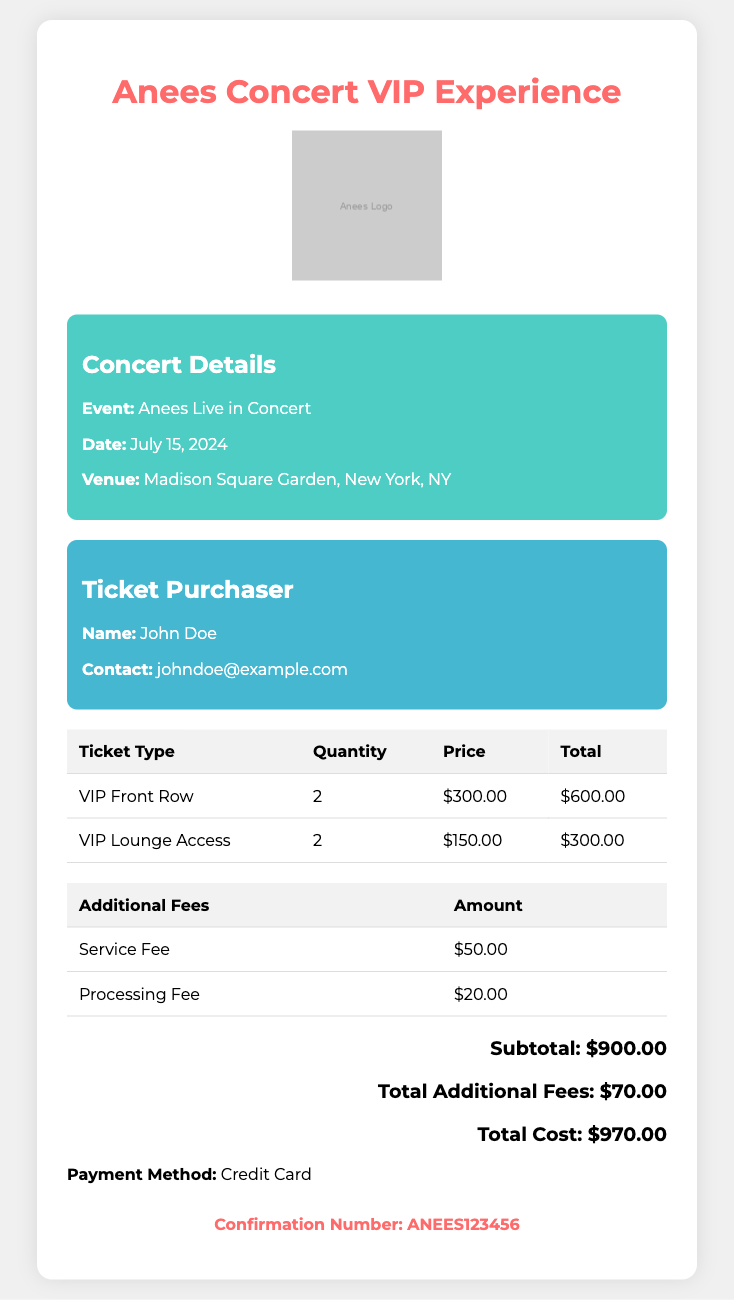what is the event name? The event name is highlighted in the concert details section, which is "Anees Live in Concert."
Answer: Anees Live in Concert what is the date of the concert? The date of the concert is specified in the concert details section as July 15, 2024.
Answer: July 15, 2024 how many VIP Front Row tickets were purchased? The quantity of VIP Front Row tickets purchased is listed in the ticket table, showing 2 tickets.
Answer: 2 what is the total for VIP Lounge Access tickets? The total for VIP Lounge Access tickets is calculated in the ticket table, which shows $300.00.
Answer: $300.00 what is the subtotal amount? The subtotal amount is displayed in the total cost section as $900.00 before the additional fees.
Answer: $900.00 what are the total additional fees? The total additional fees are summarized in the document as $70.00 from the service and processing fees.
Answer: $70.00 who is the ticket purchaser? The ticket purchaser's name is mentioned in the purchaser info section, which is John Doe.
Answer: John Doe what is the payment method used? The payment method is noted in the document, specifically stating "Credit Card."
Answer: Credit Card what is the confirmation number? The confirmation number is provided in the confirmation section, which is ANEES123456.
Answer: ANEES123456 